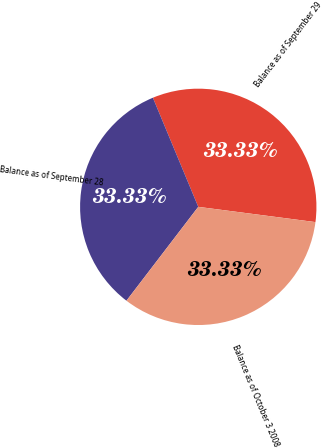Convert chart. <chart><loc_0><loc_0><loc_500><loc_500><pie_chart><fcel>Balance as of September 29<fcel>Balance as of September 28<fcel>Balance as of October 3 2008<nl><fcel>33.33%<fcel>33.33%<fcel>33.33%<nl></chart> 